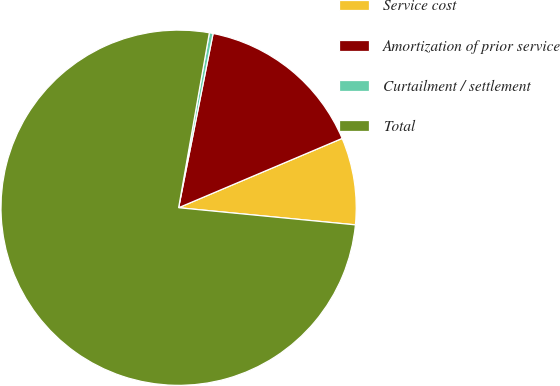<chart> <loc_0><loc_0><loc_500><loc_500><pie_chart><fcel>Service cost<fcel>Amortization of prior service<fcel>Curtailment / settlement<fcel>Total<nl><fcel>7.92%<fcel>15.51%<fcel>0.34%<fcel>76.23%<nl></chart> 